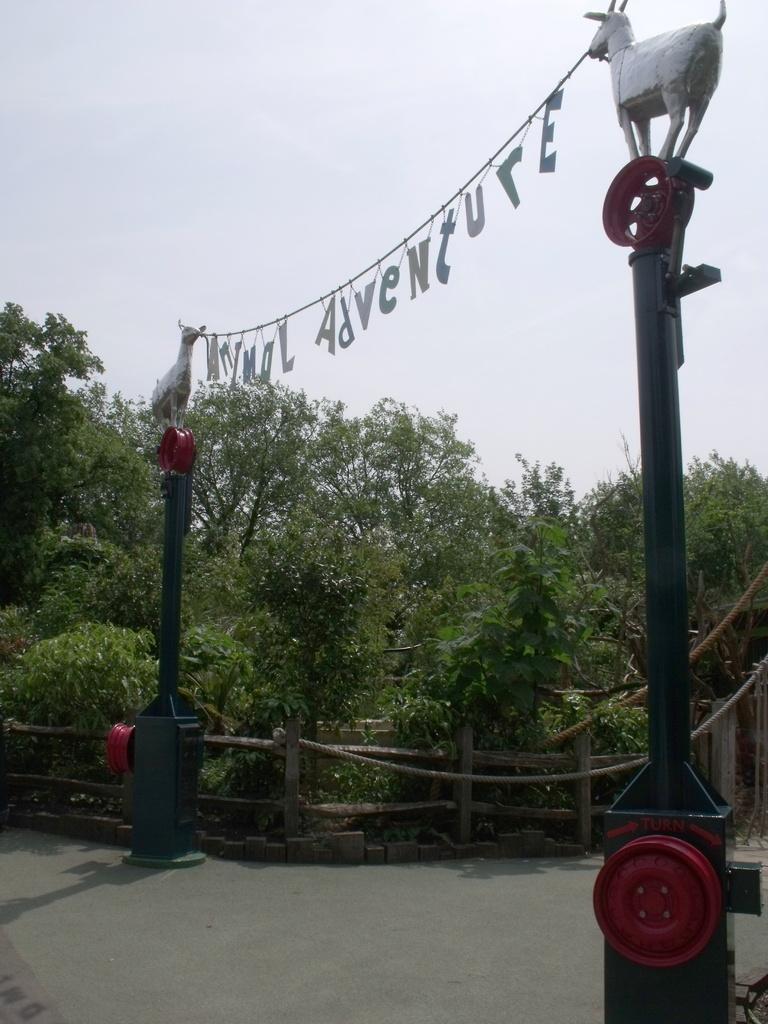Describe this image in one or two sentences. In this picture we can see few poles, trees, wooden fence and sculptures. 